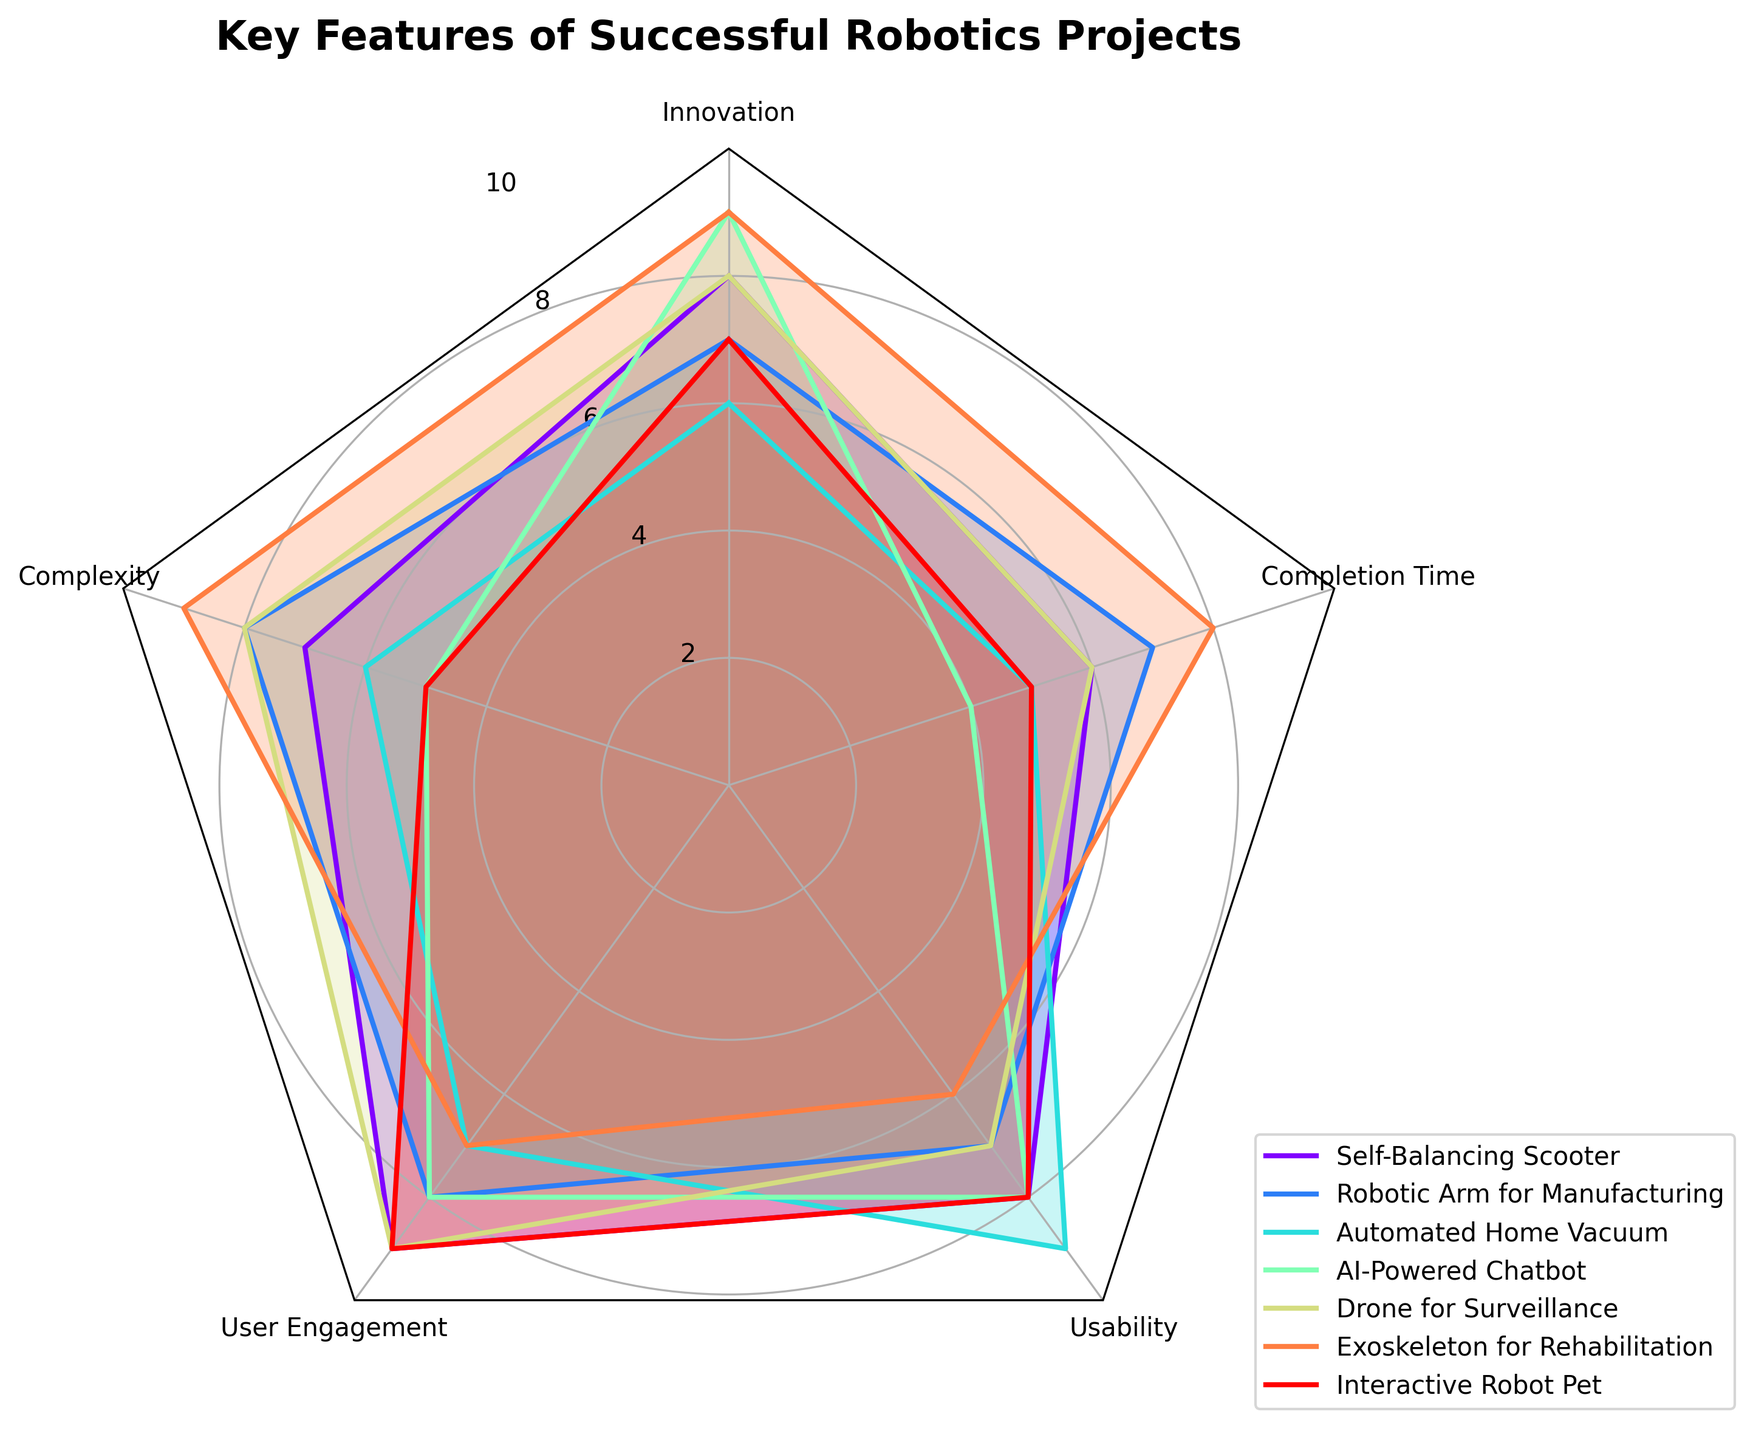What is the title of the radar chart? The title is displayed at the top of the chart and summarizes what the radar chart is about. It reads "Key Features of Successful Robotics Projects."
Answer: Key Features of Successful Robotics Projects How many features are being compared in the radar chart? The chart has axes for each feature being compared. Count the number of axes or label names. There are five features: Innovation, Complexity, User Engagement, Usability, Completion Time.
Answer: Five Which project has the highest rating for "Innovation"? Look for the project whose radar chart line is furthest from the center on the "Innovation" axis. Both the AI-Powered Chatbot and Exoskeleton for Rehabilitation have the highest Innovation rating of 9.
Answer: AI-Powered Chatbot or Exoskeleton for Rehabilitation Which project excels the most in "User Engagement"? On the "User Engagement" axis, identify the project with the highest marked point. Projects with a rating of 9 are Self-Balancing Scooter, Drone for Surveillance, and Interactive Robot Pet.
Answer: Self-Balancing Scooter, Drone for Surveillance, Interactive Robot Pet Which project has the best balance across all five features? To find the best balance, look for a project whose radar chart line is the most evenly distributed and fills a larger regular polygon. The Robotic Arm for Manufacturing has relatively high and consistent scores across all features.
Answer: Robotic Arm for Manufacturing Which two projects have the largest difference in "Usability"? Check the lowest and highest points on the "Usability" axis. The Automated Home Vacuum has the highest usability rating of 9, and Exoskeleton for Rehabilitation has the lowest usability rating of 6. The difference is 3.
Answer: Automated Home Vacuum and Exoskeleton for Rehabilitation What is the average "Completion Time" rating for all projects? Add the Completion Time ratings and divide by the number of projects: (6 + 7 + 5 + 4 + 6 + 8 + 5) / 7 = 5.857.
Answer: 5.857 Which project is rated the lowest in terms of "Complexity"? On the "Complexity" axis, identify the project with the smallest marked value. The AI-Powered Chatbot and Interactive Robot Pet have the lowest Complexity rating of 5.
Answer: AI-Powered Chatbot or Interactive Robot Pet If you combine the scores for "Innovation" and "Complexity", which project has the highest combined score? Add the Innovation and Complexity ratings and see which project has the highest value: Self-Balancing Scooter (15), Robotic Arm for Manufacturing (15), Automated Home Vacuum (12), AI-Powered Chatbot (14), Drone for Surveillance (16), Exoskeleton for Rehabilitation (18), Interactive Robot Pet (12). The Exoskeleton for Rehabilitation has the highest combined score of 18.
Answer: Exoskeleton for Rehabilitation 